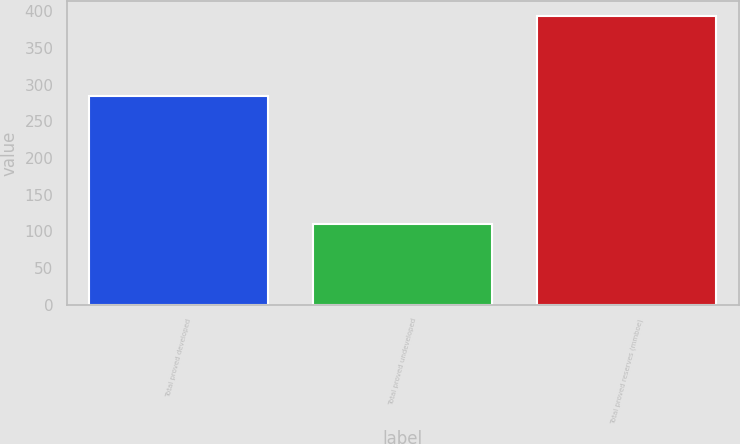Convert chart. <chart><loc_0><loc_0><loc_500><loc_500><bar_chart><fcel>Total proved developed<fcel>Total proved undeveloped<fcel>Total proved reserves (mmboe)<nl><fcel>284<fcel>110<fcel>394<nl></chart> 